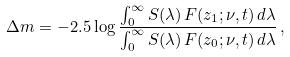<formula> <loc_0><loc_0><loc_500><loc_500>\Delta m = - 2 . 5 \log \frac { \int _ { 0 } ^ { \infty } S ( \lambda ) \, F ( z _ { 1 } ; \nu , t ) \, d \lambda } { \int _ { 0 } ^ { \infty } S ( \lambda ) \, F ( z _ { 0 } ; \nu , t ) \, d \lambda } \, ,</formula> 